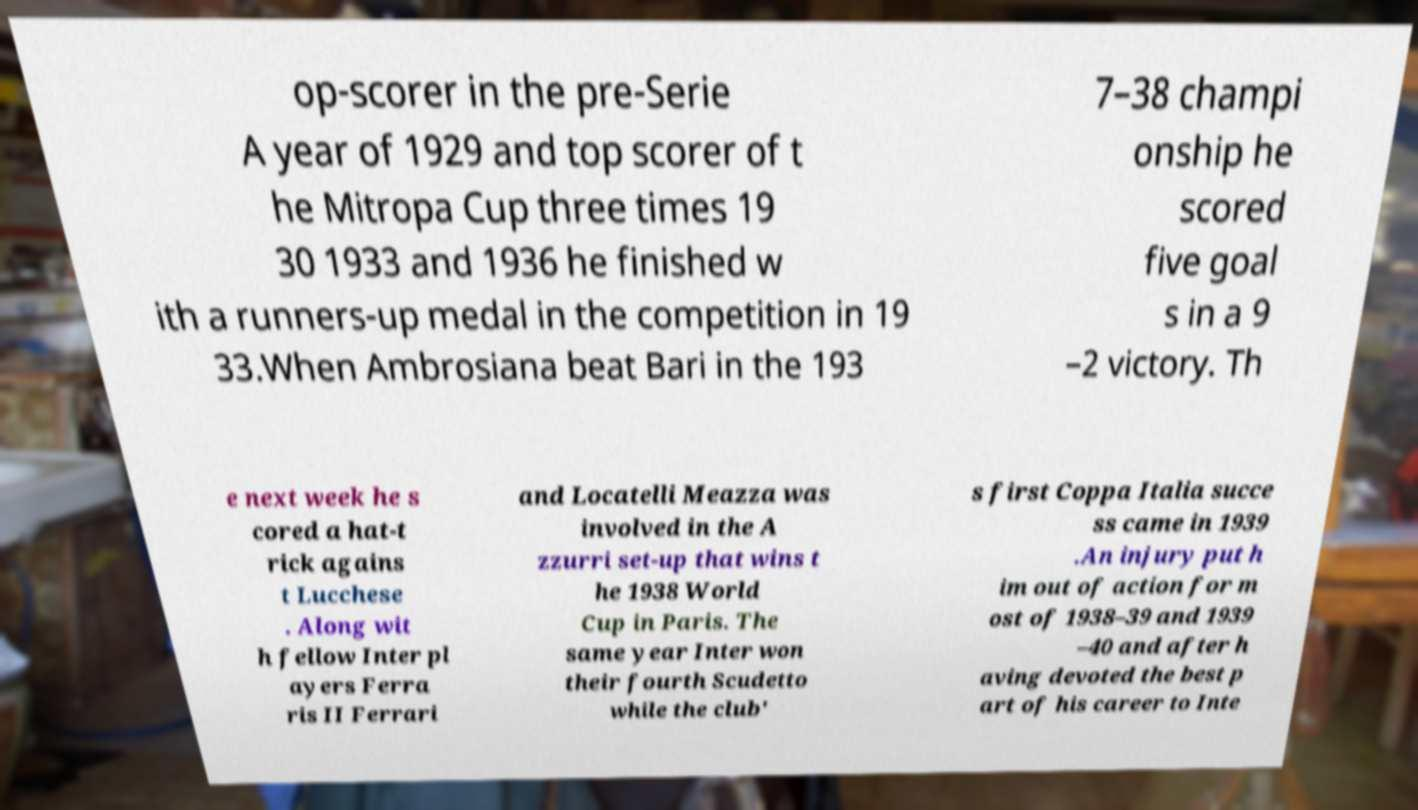Could you extract and type out the text from this image? op-scorer in the pre-Serie A year of 1929 and top scorer of t he Mitropa Cup three times 19 30 1933 and 1936 he finished w ith a runners-up medal in the competition in 19 33.When Ambrosiana beat Bari in the 193 7–38 champi onship he scored five goal s in a 9 –2 victory. Th e next week he s cored a hat-t rick agains t Lucchese . Along wit h fellow Inter pl ayers Ferra ris II Ferrari and Locatelli Meazza was involved in the A zzurri set-up that wins t he 1938 World Cup in Paris. The same year Inter won their fourth Scudetto while the club' s first Coppa Italia succe ss came in 1939 .An injury put h im out of action for m ost of 1938–39 and 1939 –40 and after h aving devoted the best p art of his career to Inte 